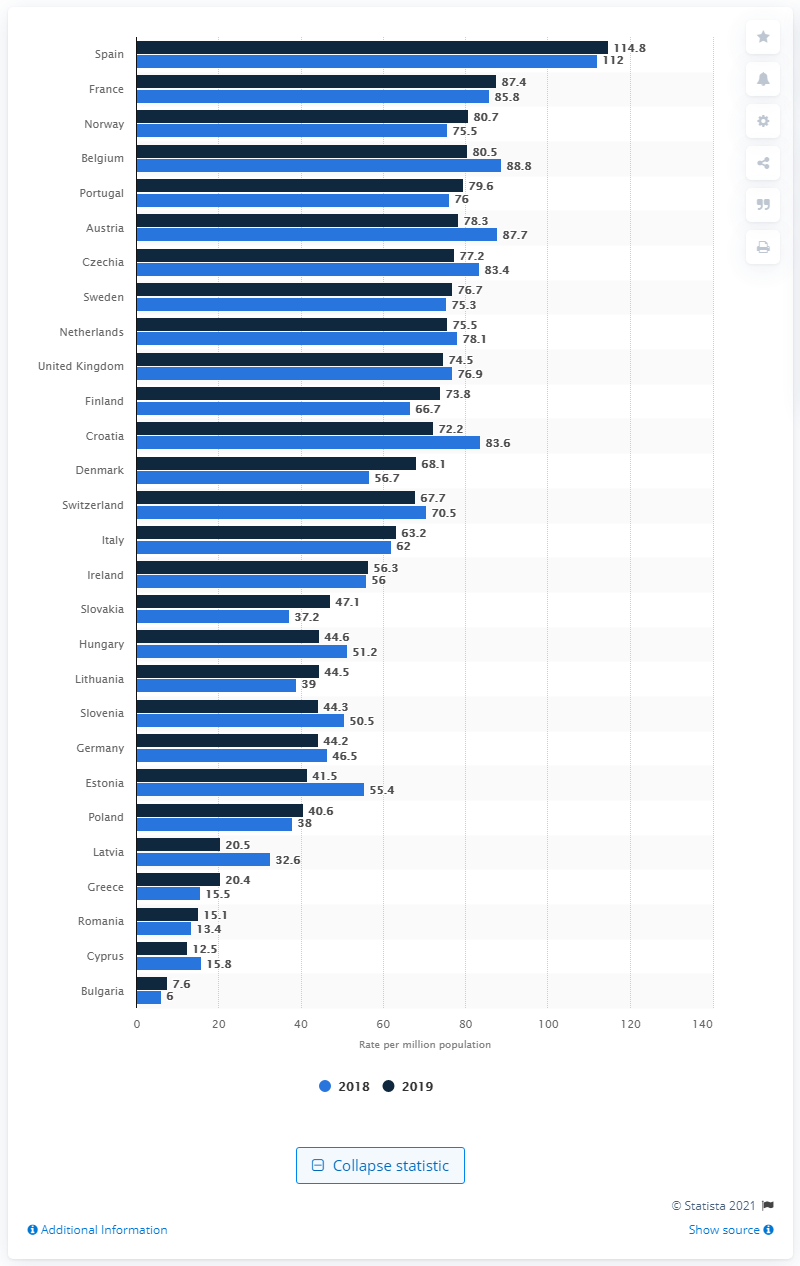Give some essential details in this illustration. Denmark had the largest rate increase between the years. 